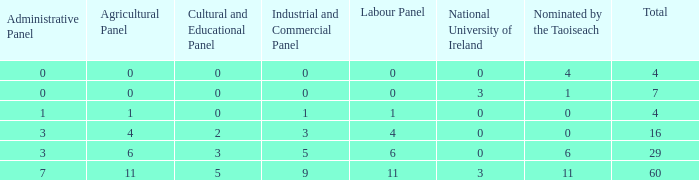What is the average nominated of the composition nominated by Taioseach with an Industrial and Commercial panel less than 9, an administrative panel greater than 0, a cultural and educational panel greater than 2, and a total less than 29? None. 